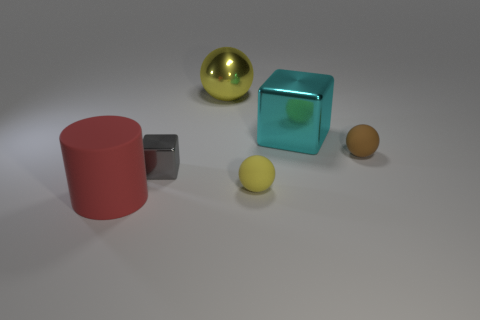Add 1 small cyan blocks. How many objects exist? 7 Subtract all small matte spheres. How many spheres are left? 1 Subtract all yellow spheres. How many spheres are left? 1 Subtract all blue cubes. How many yellow spheres are left? 2 Subtract all cylinders. How many objects are left? 5 Subtract 1 blocks. How many blocks are left? 1 Subtract 1 cyan blocks. How many objects are left? 5 Subtract all gray blocks. Subtract all yellow spheres. How many blocks are left? 1 Subtract all large cyan matte objects. Subtract all yellow rubber objects. How many objects are left? 5 Add 6 small metal cubes. How many small metal cubes are left? 7 